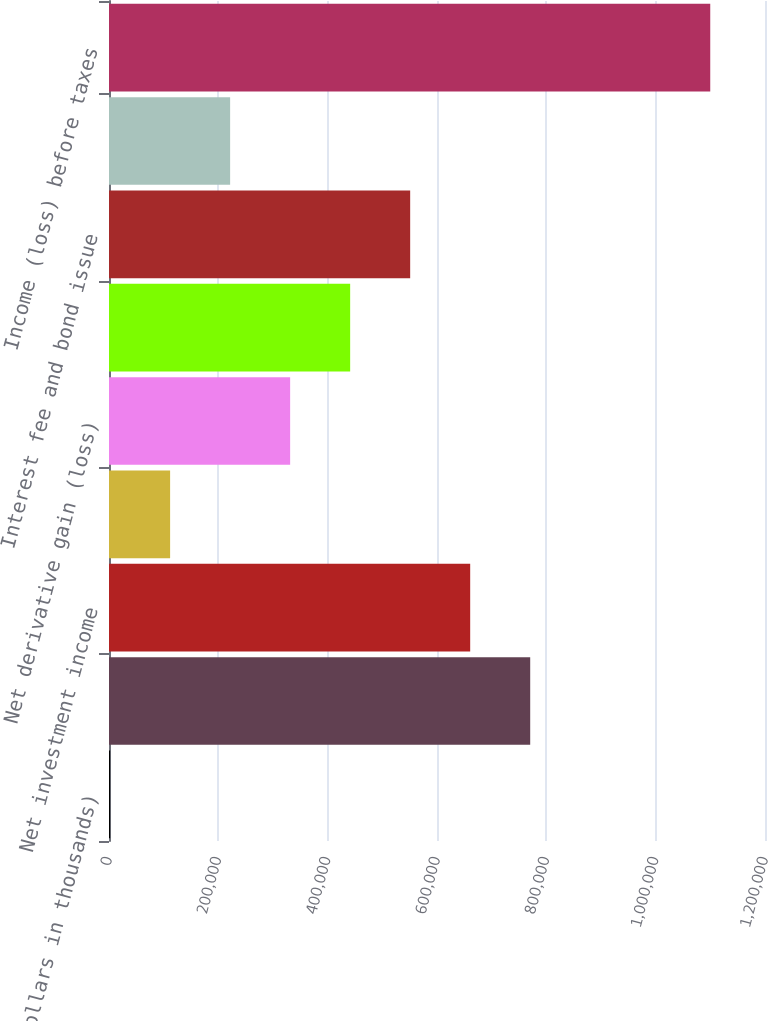<chart> <loc_0><loc_0><loc_500><loc_500><bar_chart><fcel>(Dollars in thousands)<fcel>Underwriting gain (loss)<fcel>Net investment income<fcel>Net realized capital gains<fcel>Net derivative gain (loss)<fcel>Corporate expenses<fcel>Interest fee and bond issue<fcel>Other income (expense)<fcel>Income (loss) before taxes<nl><fcel>2016<fcel>770496<fcel>660713<fcel>111799<fcel>331364<fcel>441147<fcel>550930<fcel>221582<fcel>1.09984e+06<nl></chart> 